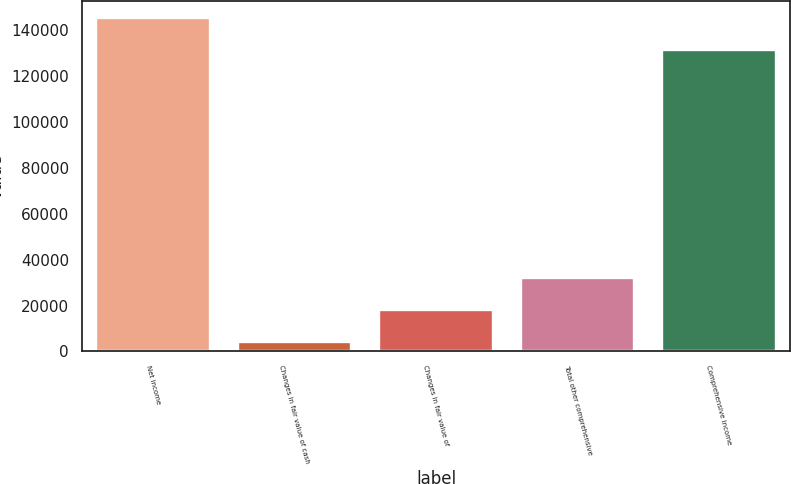Convert chart to OTSL. <chart><loc_0><loc_0><loc_500><loc_500><bar_chart><fcel>Net income<fcel>Changes in fair value of cash<fcel>Changes in fair value of<fcel>Total other comprehensive<fcel>Comprehensive income<nl><fcel>145155<fcel>4168<fcel>18153.4<fcel>32138.8<fcel>131170<nl></chart> 